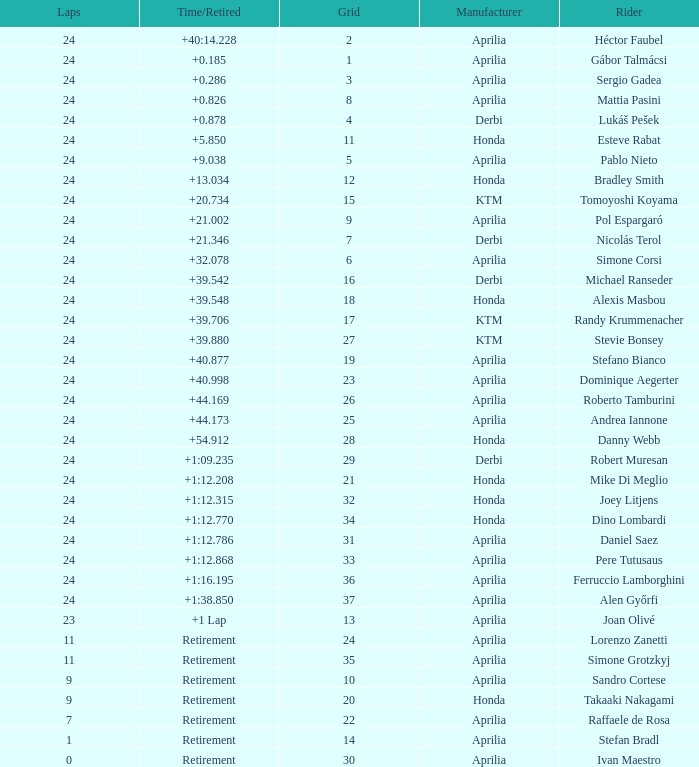Who manufactured the motorcycle that did 24 laps and 9 grids? Aprilia. 